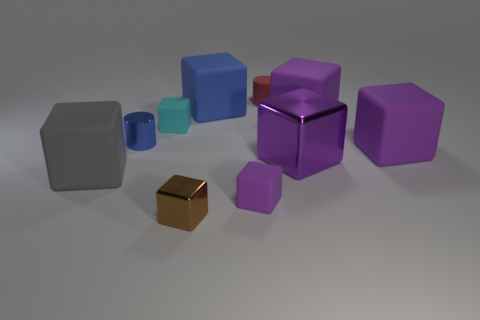There is a thing that is the same color as the shiny cylinder; what size is it?
Make the answer very short. Large. What number of other things are the same size as the red rubber cylinder?
Give a very brief answer. 4. There is a tiny blue cylinder that is in front of the small cyan cube; what is it made of?
Offer a terse response. Metal. What shape is the tiny metallic object behind the metal cube that is to the right of the cylinder right of the small metal cube?
Provide a short and direct response. Cylinder. Does the gray object have the same size as the brown metallic object?
Provide a succinct answer. No. What number of things are either large gray blocks or things that are to the right of the small rubber cylinder?
Offer a terse response. 4. What number of objects are big things to the left of the tiny metallic cube or large cubes on the right side of the gray matte block?
Your response must be concise. 5. Are there any metal things in front of the large gray thing?
Your response must be concise. Yes. What is the color of the large rubber thing right of the purple thing behind the big purple matte object that is in front of the tiny blue thing?
Ensure brevity in your answer.  Purple. Does the brown metallic object have the same shape as the big blue matte thing?
Keep it short and to the point. Yes. 